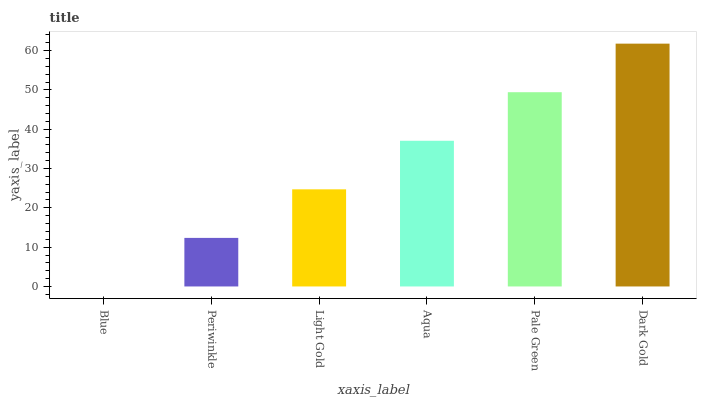Is Blue the minimum?
Answer yes or no. Yes. Is Dark Gold the maximum?
Answer yes or no. Yes. Is Periwinkle the minimum?
Answer yes or no. No. Is Periwinkle the maximum?
Answer yes or no. No. Is Periwinkle greater than Blue?
Answer yes or no. Yes. Is Blue less than Periwinkle?
Answer yes or no. Yes. Is Blue greater than Periwinkle?
Answer yes or no. No. Is Periwinkle less than Blue?
Answer yes or no. No. Is Aqua the high median?
Answer yes or no. Yes. Is Light Gold the low median?
Answer yes or no. Yes. Is Light Gold the high median?
Answer yes or no. No. Is Dark Gold the low median?
Answer yes or no. No. 